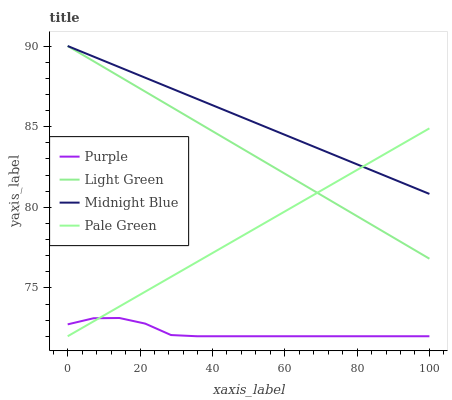Does Purple have the minimum area under the curve?
Answer yes or no. Yes. Does Midnight Blue have the maximum area under the curve?
Answer yes or no. Yes. Does Pale Green have the minimum area under the curve?
Answer yes or no. No. Does Pale Green have the maximum area under the curve?
Answer yes or no. No. Is Light Green the smoothest?
Answer yes or no. Yes. Is Purple the roughest?
Answer yes or no. Yes. Is Pale Green the smoothest?
Answer yes or no. No. Is Pale Green the roughest?
Answer yes or no. No. Does Purple have the lowest value?
Answer yes or no. Yes. Does Midnight Blue have the lowest value?
Answer yes or no. No. Does Light Green have the highest value?
Answer yes or no. Yes. Does Pale Green have the highest value?
Answer yes or no. No. Is Purple less than Light Green?
Answer yes or no. Yes. Is Midnight Blue greater than Purple?
Answer yes or no. Yes. Does Purple intersect Pale Green?
Answer yes or no. Yes. Is Purple less than Pale Green?
Answer yes or no. No. Is Purple greater than Pale Green?
Answer yes or no. No. Does Purple intersect Light Green?
Answer yes or no. No. 